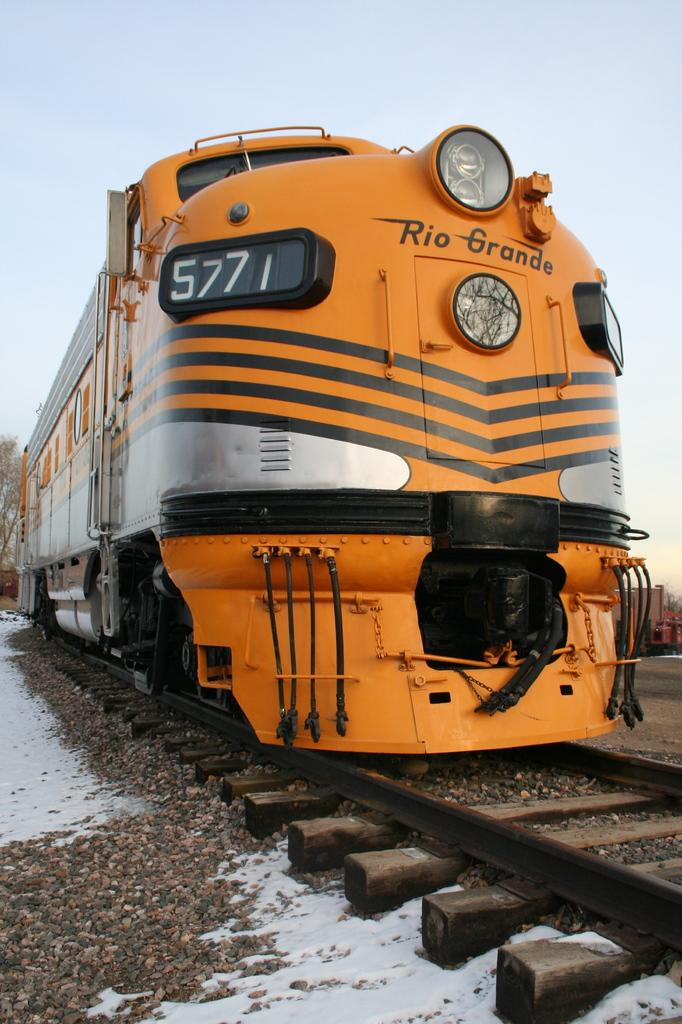What is the main subject in the center of the image? There is a train in the center of the image on the track. What can be seen at the bottom side of the image? Pebbles and snow are visible at the bottom side of the image. What is in the background of the image? There is a tree and a container in the background of the image. What flavor of corn is being eaten by the train in the image? There is no corn present in the image, and the train is not eating anything. 